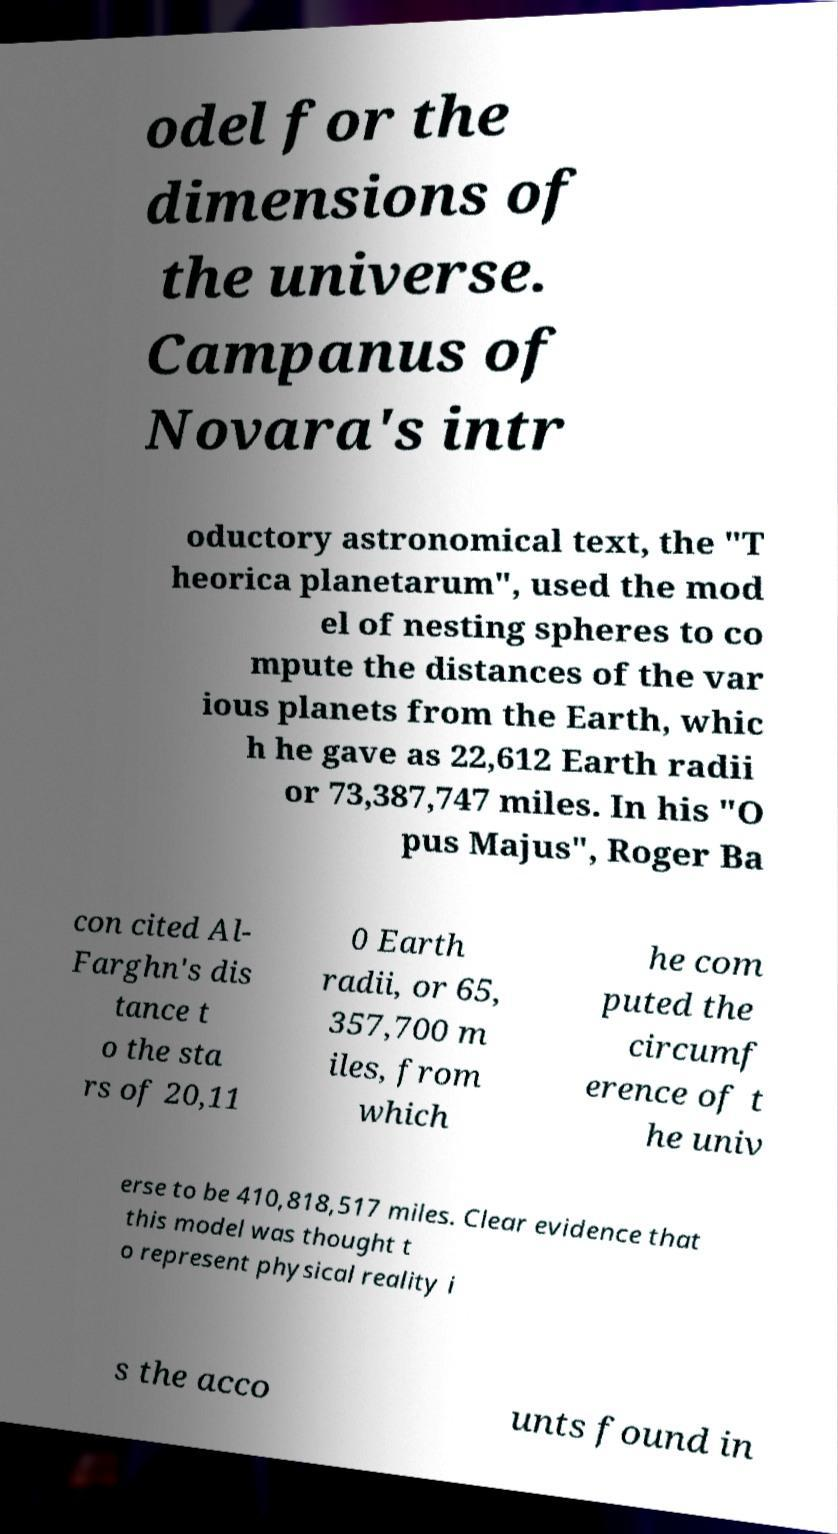What messages or text are displayed in this image? I need them in a readable, typed format. odel for the dimensions of the universe. Campanus of Novara's intr oductory astronomical text, the "T heorica planetarum", used the mod el of nesting spheres to co mpute the distances of the var ious planets from the Earth, whic h he gave as 22,612 Earth radii or 73,387,747 miles. In his "O pus Majus", Roger Ba con cited Al- Farghn's dis tance t o the sta rs of 20,11 0 Earth radii, or 65, 357,700 m iles, from which he com puted the circumf erence of t he univ erse to be 410,818,517 miles. Clear evidence that this model was thought t o represent physical reality i s the acco unts found in 